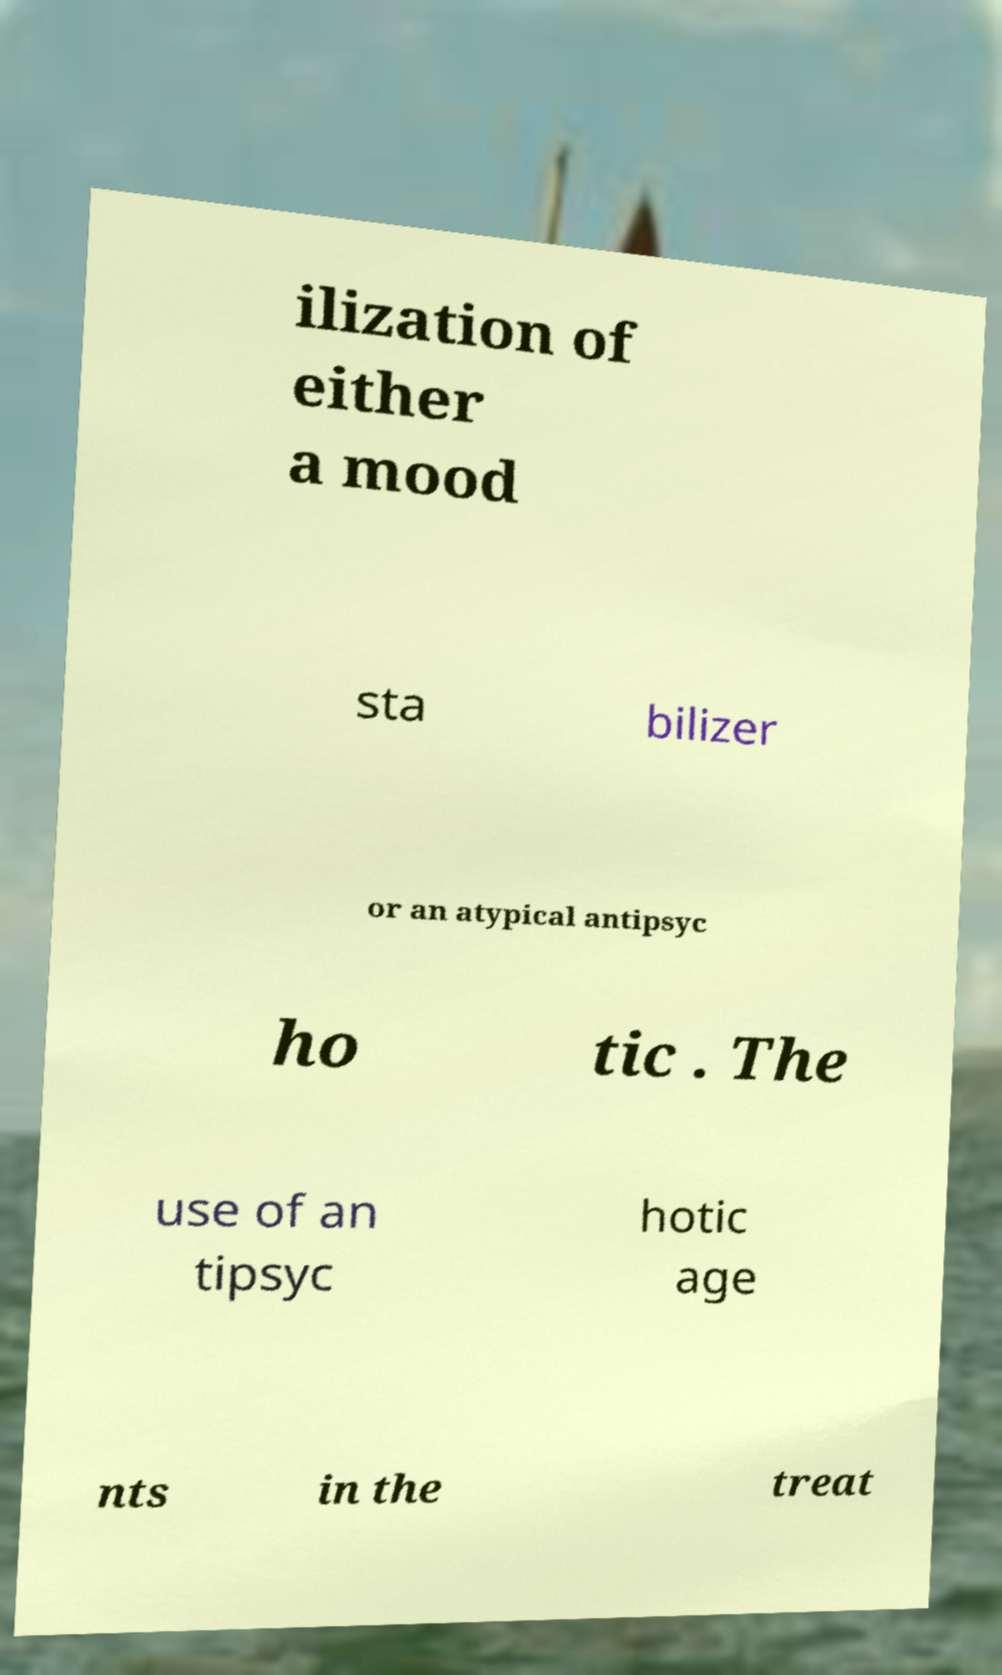Can you accurately transcribe the text from the provided image for me? ilization of either a mood sta bilizer or an atypical antipsyc ho tic . The use of an tipsyc hotic age nts in the treat 